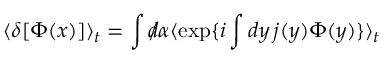<formula> <loc_0><loc_0><loc_500><loc_500>\langle \delta [ \Phi ( x ) ] \rangle _ { t } = \int d \, / \alpha \langle \exp \{ i \int d y \, j ( y ) \Phi ( y ) \} \rangle _ { t }</formula> 